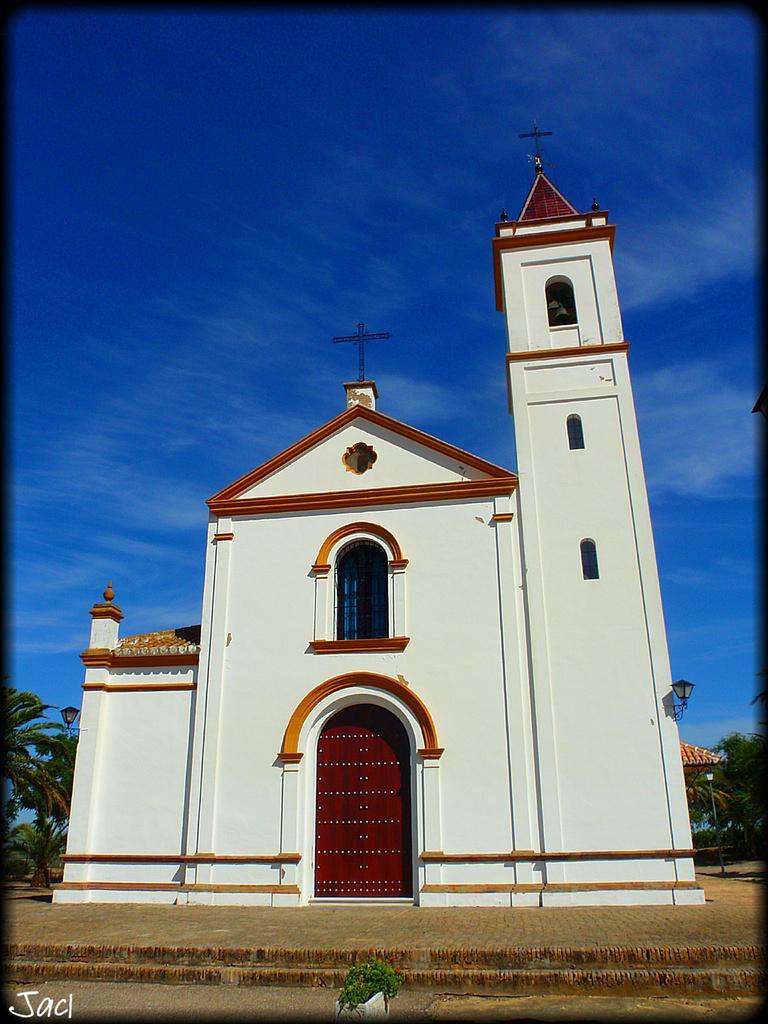How would you summarize this image in a sentence or two? In this image there is a church building in white color with cross on the top, behind that there are so many trees. 